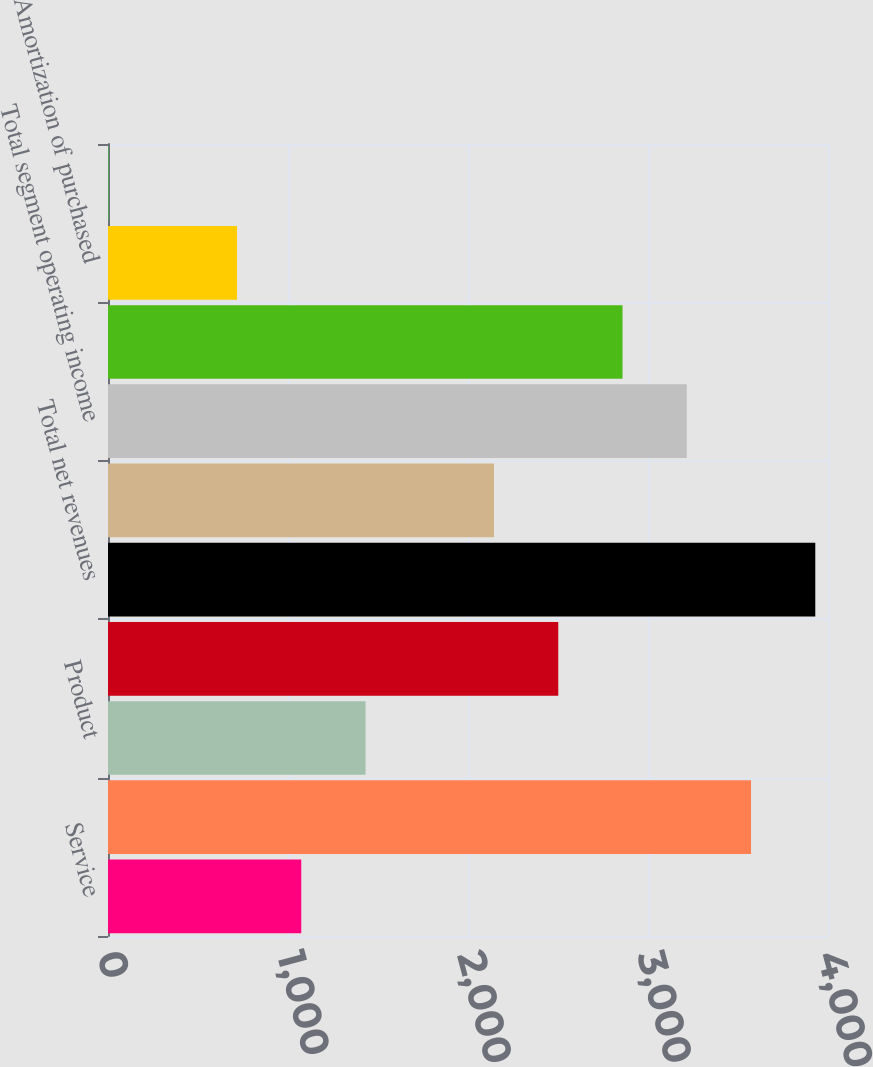Convert chart to OTSL. <chart><loc_0><loc_0><loc_500><loc_500><bar_chart><fcel>Service<fcel>Total Infrastructure revenues<fcel>Product<fcel>Total Service Layer<fcel>Total net revenues<fcel>Infrastructure<fcel>Total segment operating income<fcel>Total management operating<fcel>Amortization of purchased<fcel>Stock-based payroll tax<nl><fcel>1073.68<fcel>3572.4<fcel>1430.64<fcel>2501.52<fcel>3929.36<fcel>2144.56<fcel>3215.44<fcel>2858.48<fcel>716.72<fcel>2.8<nl></chart> 